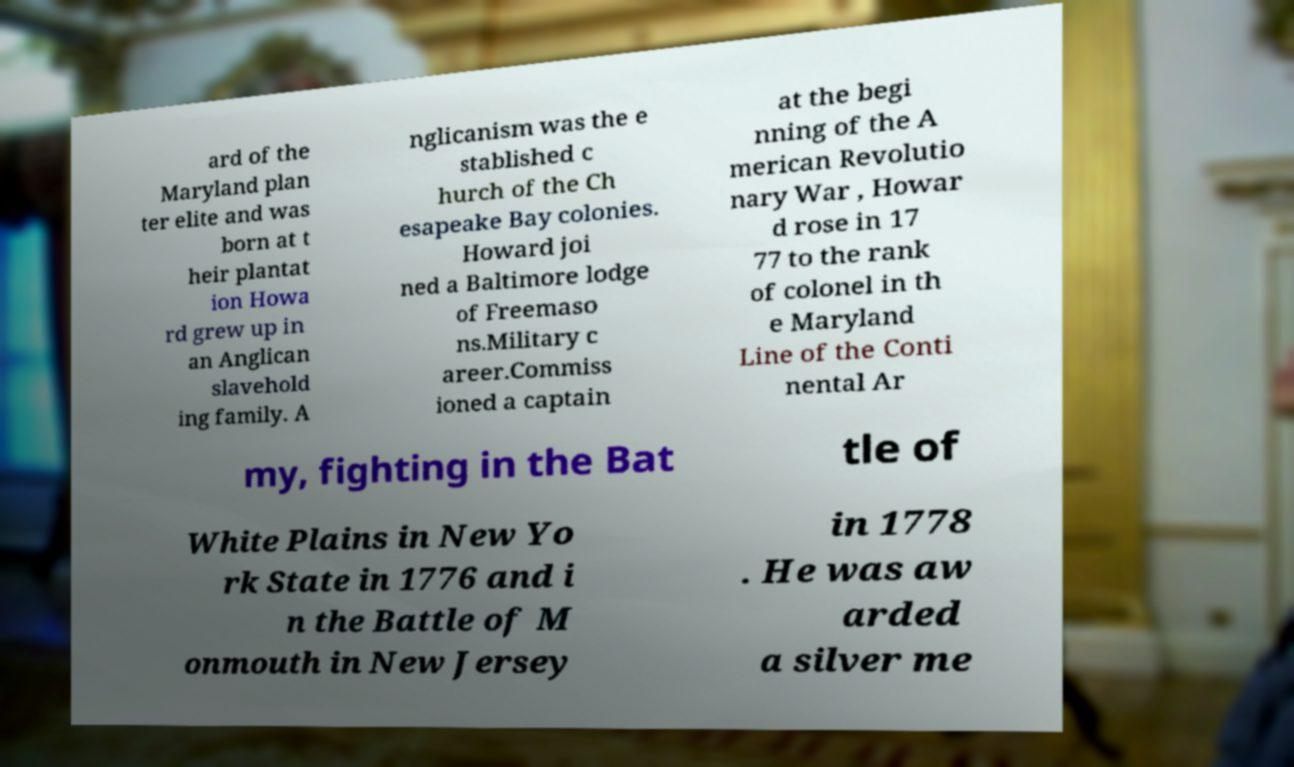I need the written content from this picture converted into text. Can you do that? ard of the Maryland plan ter elite and was born at t heir plantat ion Howa rd grew up in an Anglican slavehold ing family. A nglicanism was the e stablished c hurch of the Ch esapeake Bay colonies. Howard joi ned a Baltimore lodge of Freemaso ns.Military c areer.Commiss ioned a captain at the begi nning of the A merican Revolutio nary War , Howar d rose in 17 77 to the rank of colonel in th e Maryland Line of the Conti nental Ar my, fighting in the Bat tle of White Plains in New Yo rk State in 1776 and i n the Battle of M onmouth in New Jersey in 1778 . He was aw arded a silver me 